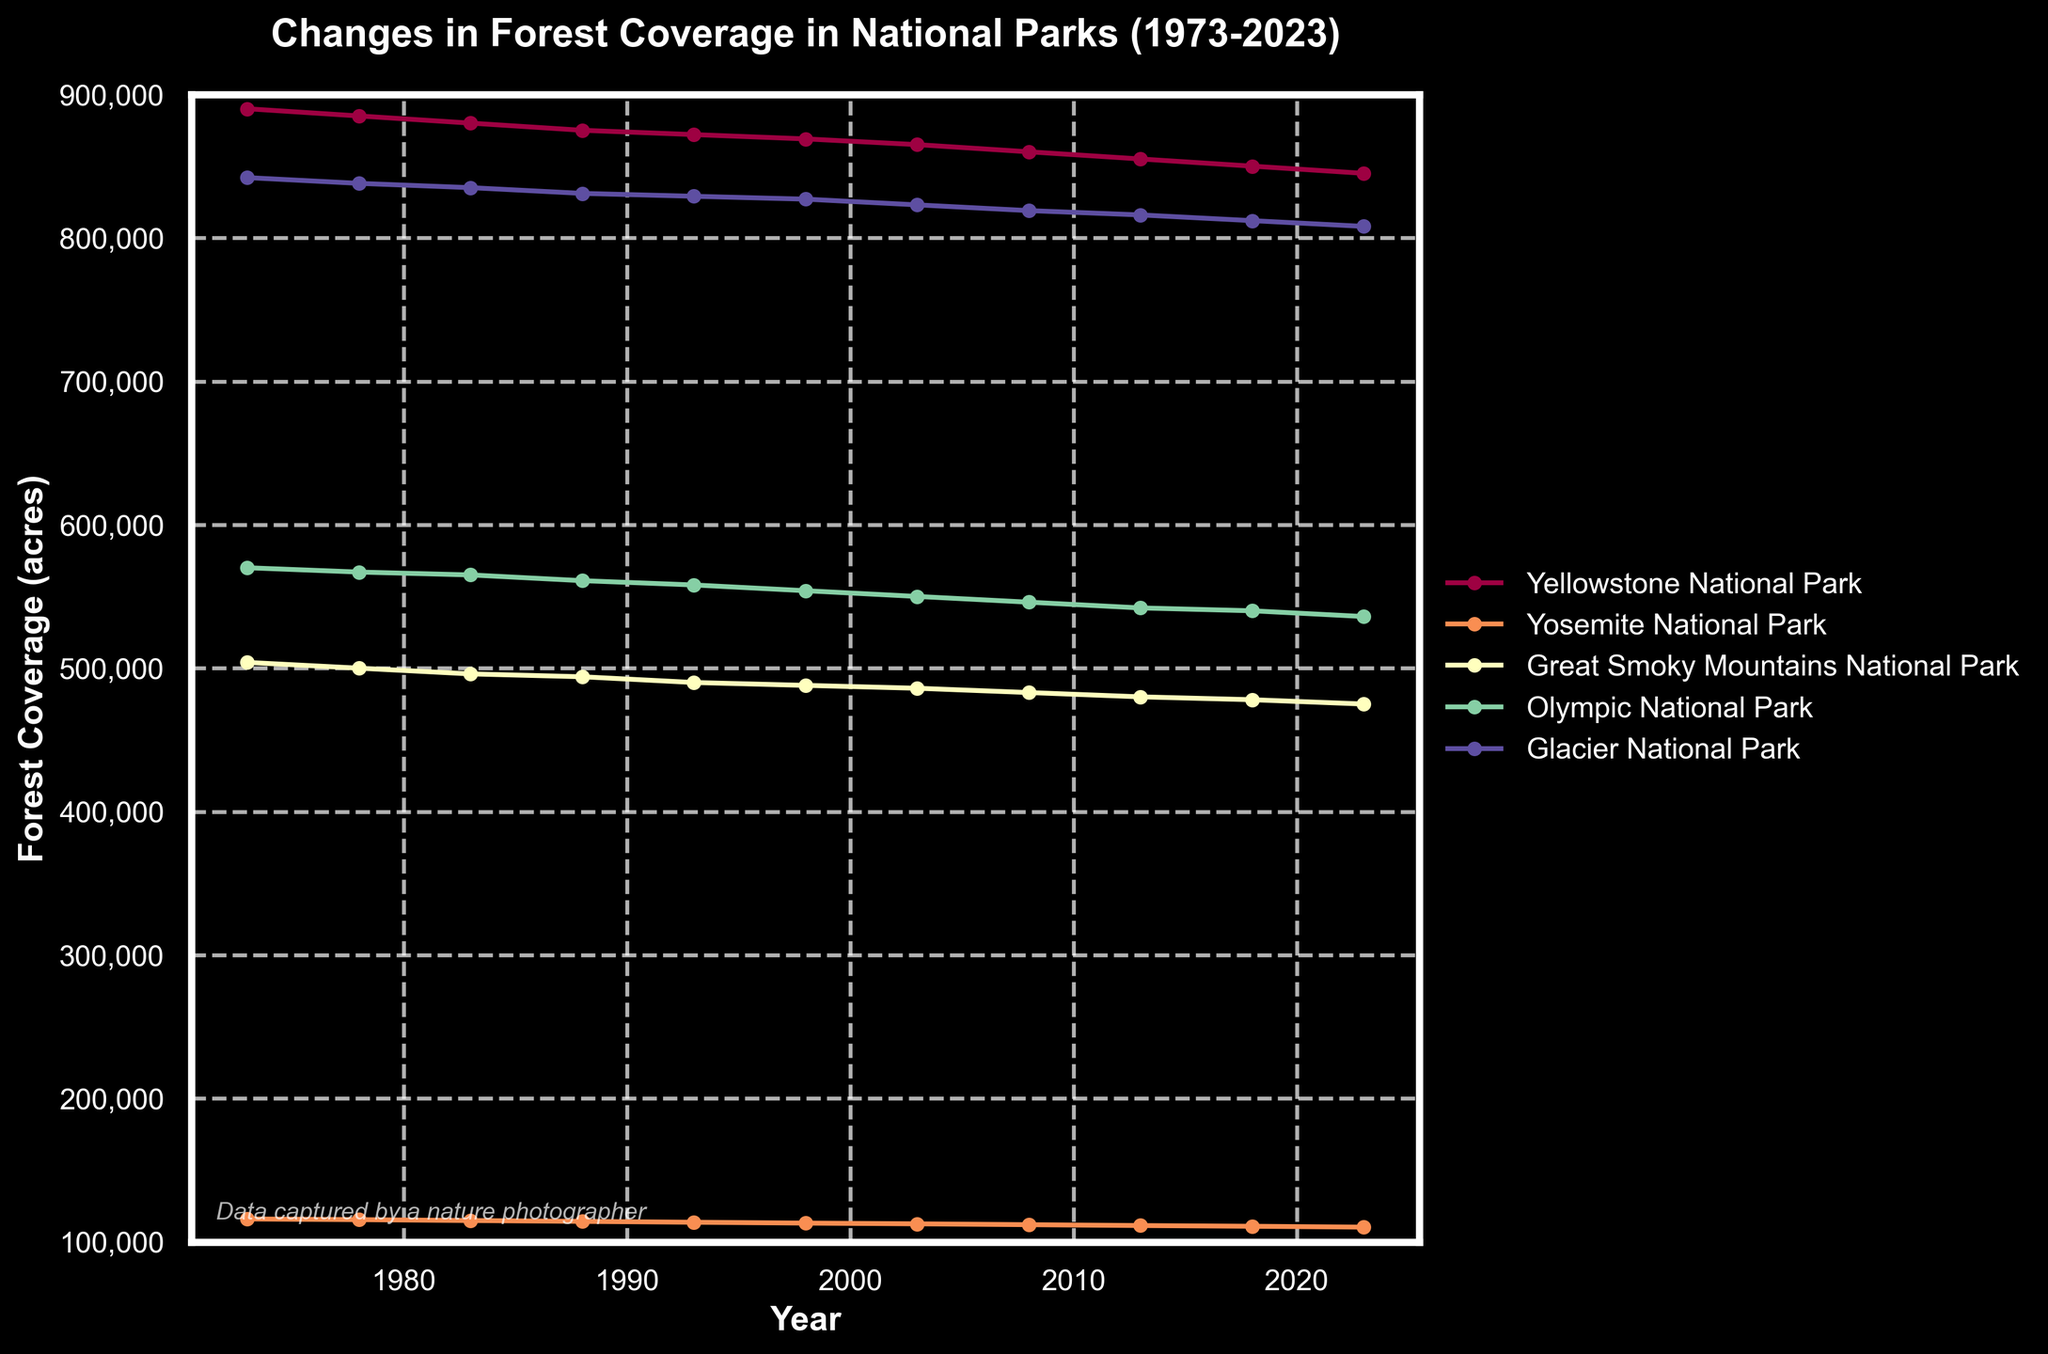what is the title of the plot? The title is located at the top of the figure and provides a summary of the figure's content. In this case, the title is "Changes in Forest Coverage in National Parks (1973-2023)."
Answer: Changes in Forest Coverage in National Parks (1973-2023) What is the forest coverage of Glacier National Park in 1983? Locate the year 1983 on the x-axis and then find the corresponding y-value for Glacier National Park in the figure. The data point should be labeled or can be interpolated from the plot line.
Answer: 835,000 acres Which National Park experienced the largest decrease in forest coverage between 1973 and 2023? Compare the y-values for each park in the years 1973 and 2023. Calculate the difference for each park (1973 value - 2023 value) and determine which park has the highest resulting value.
Answer: Yellowstone National Park Between which years did Yosemite National Park show the most noticeable decline in forest coverage? Look at the trend line for Yosemite National Park and identify the segment with the steepest slope or most substantial drop in y-value.
Answer: 1973 to 2023 What was the average forest coverage in 2023 across all parks? Sum the forest coverage values for all parks in 2023 and then divide by the number of parks (5).
Answer: 554,000 acres In which year did Olympic National Park first fall below 550,000 acres in forest coverage? Locate the plot line for Olympic National Park and find the first year where the y-value is below 550,000 acres.
Answer: 2003 How does the forest coverage trend in the Great Smoky Mountains National Park compare to that of Olympic National Park? Examine the trend lines of both parks. Identify general trends, such as whether they are increasing, decreasing, or stable, and how their slopes compare over time.
Answer: Both are decreasing, but the Great Smoky Mountains have a steadier decline Which National Park had the least amount of forest coverage in 2023? Find the lowest y-value among all parks in the year 2023.
Answer: Yosemite National Park What is the overall trend in forest coverage for all parks over the 50-year period? Look at the general direction of all the plot lines from 1973 to 2023.
Answer: Decreasing 